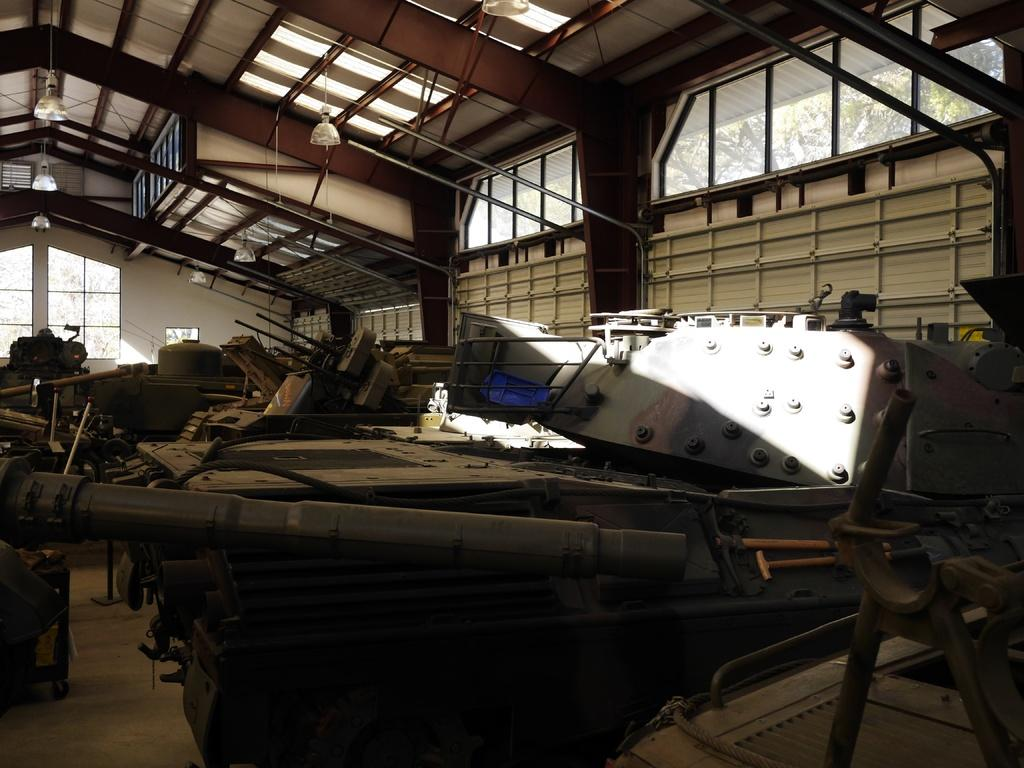What type of materials can be seen in the image? There are iron materials in the image. What specific objects made of iron can be identified? There are rods made of iron in the image. What type of windows are present in the image? There are glass windows in the image. What can be seen on the ceiling in the image? There are lights on the ceiling in the image. What natural elements can be seen through the glass windows? Branches of trees are visible through the glass windows in the image. What type of breakfast is being served on the slope in the image? There is no mention of breakfast or a slope in the image; it features iron materials, rods, glass windows, lights, and branches of trees visible through the windows. 